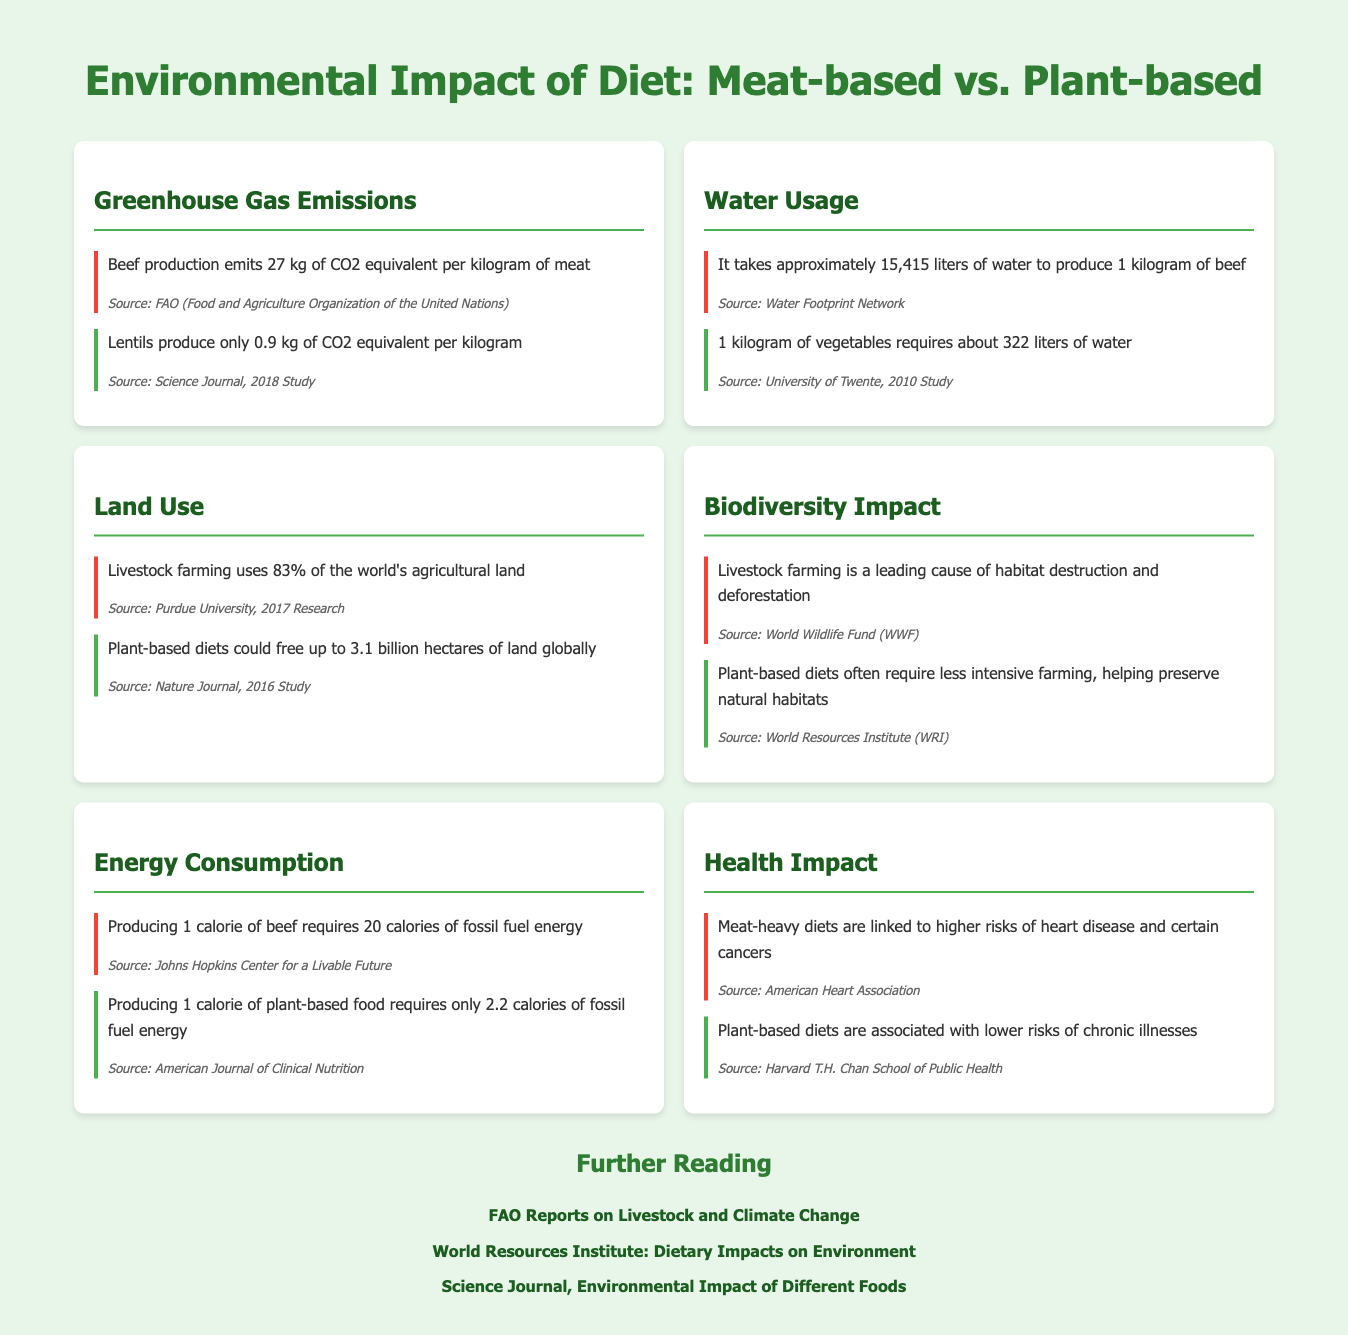what is the CO2 equivalent emission from beef production? The document states that beef production emits 27 kg of CO2 equivalent per kilogram of meat.
Answer: 27 kg how much water is required to produce 1 kilogram of vegetables? According to the document, 1 kilogram of vegetables requires about 322 liters of water.
Answer: 322 liters what percentage of the world's agricultural land is used by livestock farming? The document mentions that livestock farming uses 83% of the world's agricultural land.
Answer: 83% what is the energy requirement for producing 1 calorie of plant-based food? The document indicates that producing 1 calorie of plant-based food requires only 2.2 calories of fossil fuel energy.
Answer: 2.2 calories which diet is linked to higher risks of heart disease? The document specifies that meat-heavy diets are linked to higher risks of heart disease and certain cancers.
Answer: Meat-heavy diets how many hectares could plant-based diets potentially free up? The document states that plant-based diets could free up to 3.1 billion hectares of land globally.
Answer: 3.1 billion hectares which farming practice is a leading cause of habitat destruction? The document identifies livestock farming as a leading cause of habitat destruction and deforestation.
Answer: Livestock farming what is the greenhouse gas emission from lentils? According to the document, lentils produce only 0.9 kg of CO2 equivalent per kilogram.
Answer: 0.9 kg 